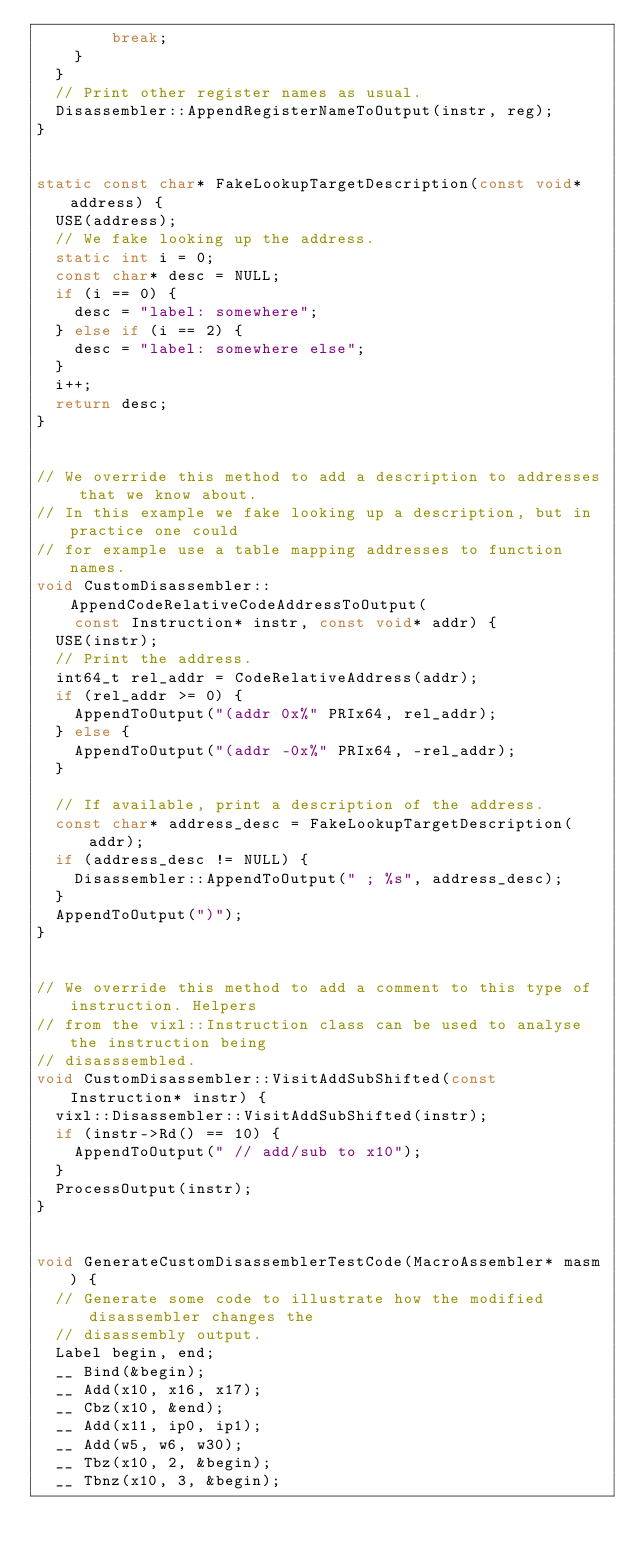Convert code to text. <code><loc_0><loc_0><loc_500><loc_500><_C++_>        break;
    }
  }
  // Print other register names as usual.
  Disassembler::AppendRegisterNameToOutput(instr, reg);
}


static const char* FakeLookupTargetDescription(const void* address) {
  USE(address);
  // We fake looking up the address.
  static int i = 0;
  const char* desc = NULL;
  if (i == 0) {
    desc = "label: somewhere";
  } else if (i == 2) {
    desc = "label: somewhere else";
  }
  i++;
  return desc;
}


// We override this method to add a description to addresses that we know about.
// In this example we fake looking up a description, but in practice one could
// for example use a table mapping addresses to function names.
void CustomDisassembler::AppendCodeRelativeCodeAddressToOutput(
    const Instruction* instr, const void* addr) {
  USE(instr);
  // Print the address.
  int64_t rel_addr = CodeRelativeAddress(addr);
  if (rel_addr >= 0) {
    AppendToOutput("(addr 0x%" PRIx64, rel_addr);
  } else {
    AppendToOutput("(addr -0x%" PRIx64, -rel_addr);
  }

  // If available, print a description of the address.
  const char* address_desc = FakeLookupTargetDescription(addr);
  if (address_desc != NULL) {
    Disassembler::AppendToOutput(" ; %s", address_desc);
  }
  AppendToOutput(")");
}


// We override this method to add a comment to this type of instruction. Helpers
// from the vixl::Instruction class can be used to analyse the instruction being
// disasssembled.
void CustomDisassembler::VisitAddSubShifted(const Instruction* instr) {
  vixl::Disassembler::VisitAddSubShifted(instr);
  if (instr->Rd() == 10) {
    AppendToOutput(" // add/sub to x10");
  }
  ProcessOutput(instr);
}


void GenerateCustomDisassemblerTestCode(MacroAssembler* masm) {
  // Generate some code to illustrate how the modified disassembler changes the
  // disassembly output.
  Label begin, end;
  __ Bind(&begin);
  __ Add(x10, x16, x17);
  __ Cbz(x10, &end);
  __ Add(x11, ip0, ip1);
  __ Add(w5, w6, w30);
  __ Tbz(x10, 2, &begin);
  __ Tbnz(x10, 3, &begin);</code> 